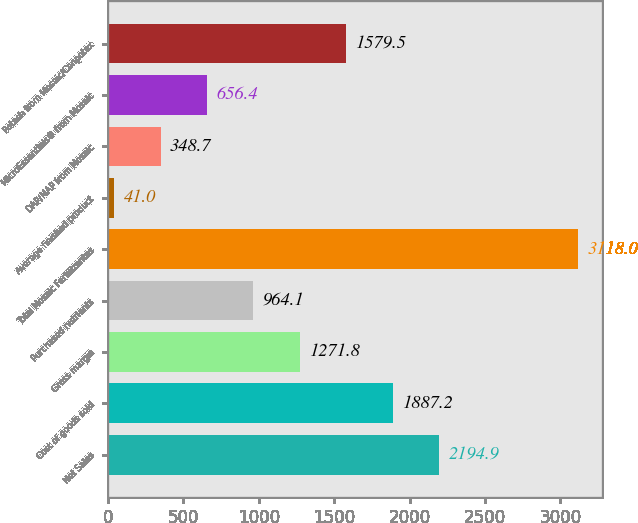<chart> <loc_0><loc_0><loc_500><loc_500><bar_chart><fcel>Net Sales<fcel>Cost of goods sold<fcel>Gross margin<fcel>Purchased nutrients<fcel>Total Mosaic Fertilizantes<fcel>Average finished product<fcel>DAP/MAP from Mosaic<fcel>MicroEssentials® from Mosaic<fcel>Potash from Mosaic/Canpotex<nl><fcel>2194.9<fcel>1887.2<fcel>1271.8<fcel>964.1<fcel>3118<fcel>41<fcel>348.7<fcel>656.4<fcel>1579.5<nl></chart> 